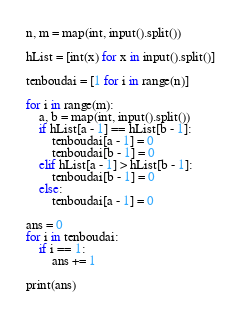Convert code to text. <code><loc_0><loc_0><loc_500><loc_500><_Python_>n, m = map(int, input().split())

hList = [int(x) for x in input().split()]

tenboudai = [1 for i in range(n)]

for i in range(m):
    a, b = map(int, input().split())
    if hList[a - 1] == hList[b - 1]:
        tenboudai[a - 1] = 0
        tenboudai[b - 1] = 0
    elif hList[a - 1] > hList[b - 1]:
        tenboudai[b - 1] = 0
    else:
        tenboudai[a - 1] = 0

ans = 0
for i in tenboudai:
    if i == 1:
        ans += 1

print(ans)</code> 